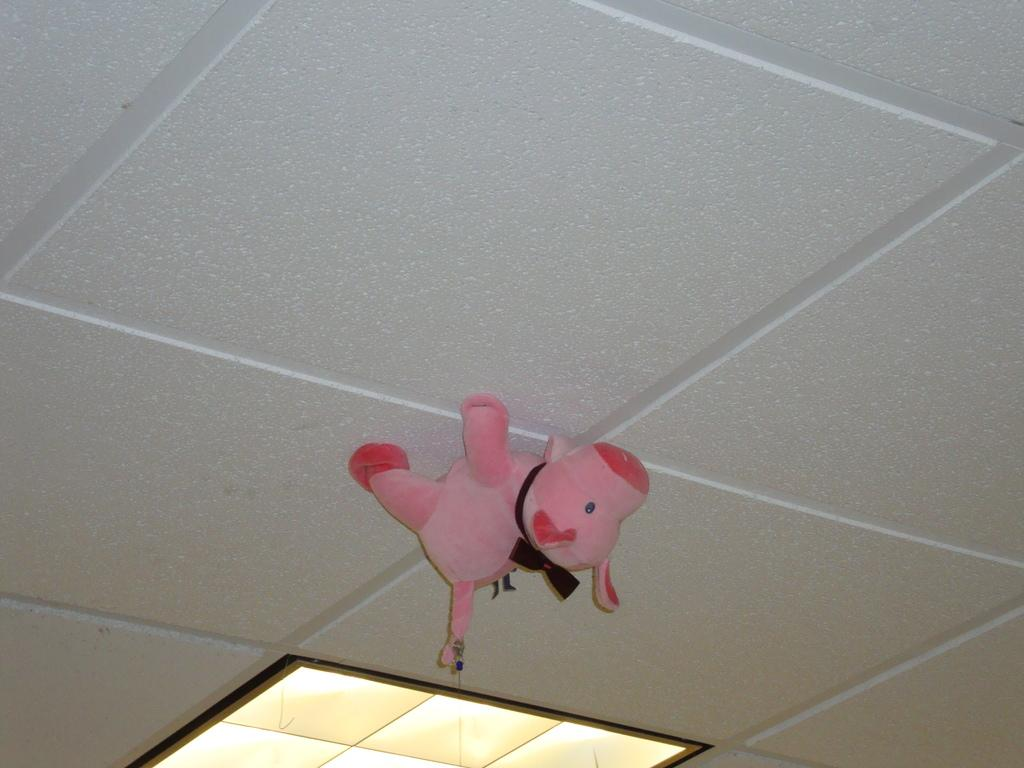What is present above the people or objects in the image? There is a ceiling in the image. What is hanging from the ceiling? There is a doll on the ceiling. Can you describe the lighting in the image? There is a light visible in the image. What type of protest is happening in the image? There is no protest present in the image; it features a doll hanging from the ceiling and a light. How many sisters are visible in the image? There is no mention of sisters in the image; it only features a doll and a light. 